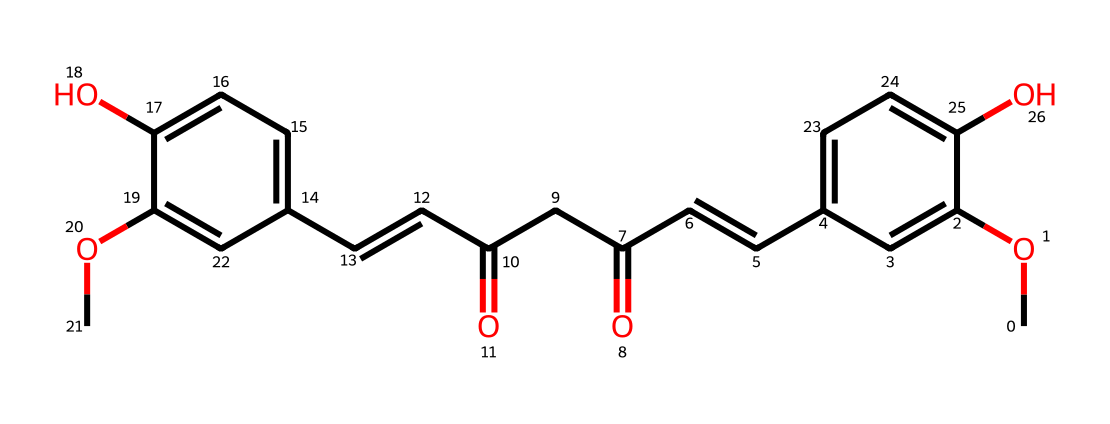How many carbon atoms are present in this molecule? By analyzing the SMILES representation, we can count the number of "C" characters, which represents carbon atoms. In the structure, there are 21 carbon atoms.
Answer: 21 What type of functional groups are present in curcumin? By examining the chemical structure represented in the SMILES, we can identify key functional groups such as hydroxyl (-OH), methoxy (-OCH3), and conjugated carbonyl groups (=O) in the compound.
Answer: hydroxyl, methoxy, carbonyl What is the degree of unsaturation in this compound? The degree of unsaturation can be calculated based on the structure. Each double bond and ring adds one to the degree. In this SMILES, there are several double bonds and no rings, leading to a total of 6 degrees of unsaturation.
Answer: 6 What is the molecular formula of curcumin based on the SMILES? To derive the molecular formula, we analyze the composition based on the SMILES: count the carbon (C), hydrogen (H), and oxygen (O) atoms. The counts yield C21H20O6.
Answer: C21H20O6 What role does the methoxy group play in curcumin's properties? The methoxy groups (–OCH3) in curcumin contribute to its lipophilicity and bioavailability, enhancing absorption in biological systems. This structural feature is crucial for its medicinal properties.
Answer: enhances absorption What specific type of compound is curcumin classified as? Curcumin is classified as a polyphenolic compound due to the presence of multiple phenolic structures in its molecular makeup.
Answer: polyphenolic What structural characteristic gives curcumin its yellow color? The presence of conjugated double bonds within the molecular structure absorbs specific wavelengths of light, resulting in the characteristic yellow color of curcumin.
Answer: conjugated double bonds 